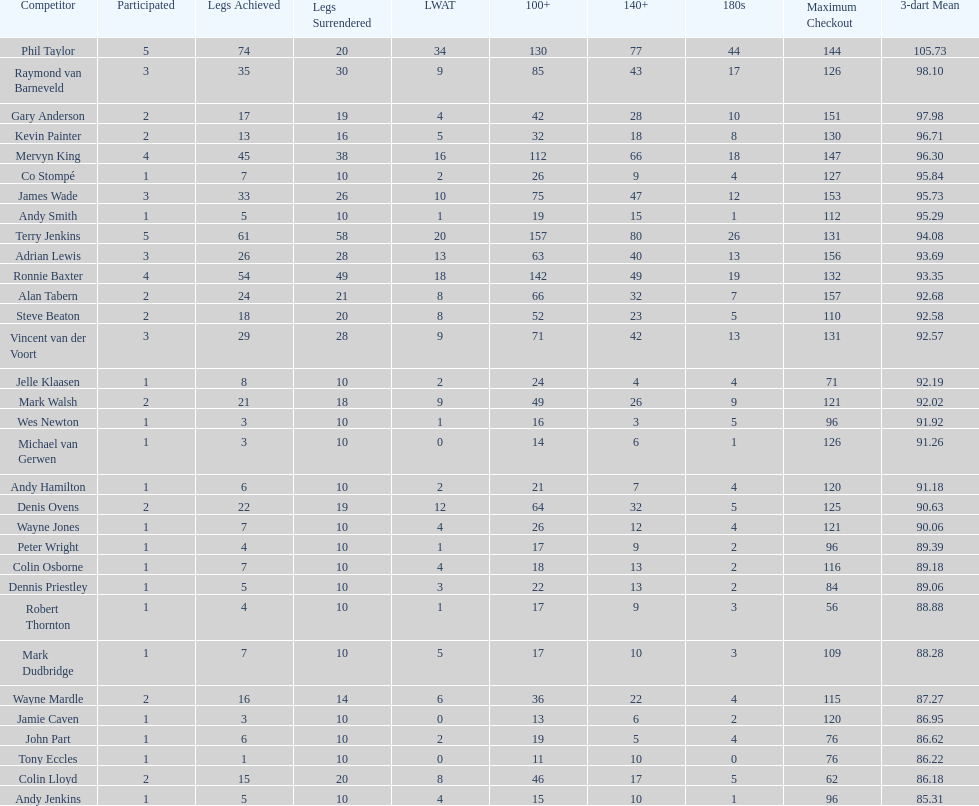Could you parse the entire table as a dict? {'header': ['Competitor', 'Participated', 'Legs Achieved', 'Legs Surrendered', 'LWAT', '100+', '140+', '180s', 'Maximum Checkout', '3-dart Mean'], 'rows': [['Phil Taylor', '5', '74', '20', '34', '130', '77', '44', '144', '105.73'], ['Raymond van Barneveld', '3', '35', '30', '9', '85', '43', '17', '126', '98.10'], ['Gary Anderson', '2', '17', '19', '4', '42', '28', '10', '151', '97.98'], ['Kevin Painter', '2', '13', '16', '5', '32', '18', '8', '130', '96.71'], ['Mervyn King', '4', '45', '38', '16', '112', '66', '18', '147', '96.30'], ['Co Stompé', '1', '7', '10', '2', '26', '9', '4', '127', '95.84'], ['James Wade', '3', '33', '26', '10', '75', '47', '12', '153', '95.73'], ['Andy Smith', '1', '5', '10', '1', '19', '15', '1', '112', '95.29'], ['Terry Jenkins', '5', '61', '58', '20', '157', '80', '26', '131', '94.08'], ['Adrian Lewis', '3', '26', '28', '13', '63', '40', '13', '156', '93.69'], ['Ronnie Baxter', '4', '54', '49', '18', '142', '49', '19', '132', '93.35'], ['Alan Tabern', '2', '24', '21', '8', '66', '32', '7', '157', '92.68'], ['Steve Beaton', '2', '18', '20', '8', '52', '23', '5', '110', '92.58'], ['Vincent van der Voort', '3', '29', '28', '9', '71', '42', '13', '131', '92.57'], ['Jelle Klaasen', '1', '8', '10', '2', '24', '4', '4', '71', '92.19'], ['Mark Walsh', '2', '21', '18', '9', '49', '26', '9', '121', '92.02'], ['Wes Newton', '1', '3', '10', '1', '16', '3', '5', '96', '91.92'], ['Michael van Gerwen', '1', '3', '10', '0', '14', '6', '1', '126', '91.26'], ['Andy Hamilton', '1', '6', '10', '2', '21', '7', '4', '120', '91.18'], ['Denis Ovens', '2', '22', '19', '12', '64', '32', '5', '125', '90.63'], ['Wayne Jones', '1', '7', '10', '4', '26', '12', '4', '121', '90.06'], ['Peter Wright', '1', '4', '10', '1', '17', '9', '2', '96', '89.39'], ['Colin Osborne', '1', '7', '10', '4', '18', '13', '2', '116', '89.18'], ['Dennis Priestley', '1', '5', '10', '3', '22', '13', '2', '84', '89.06'], ['Robert Thornton', '1', '4', '10', '1', '17', '9', '3', '56', '88.88'], ['Mark Dudbridge', '1', '7', '10', '5', '17', '10', '3', '109', '88.28'], ['Wayne Mardle', '2', '16', '14', '6', '36', '22', '4', '115', '87.27'], ['Jamie Caven', '1', '3', '10', '0', '13', '6', '2', '120', '86.95'], ['John Part', '1', '6', '10', '2', '19', '5', '4', '76', '86.62'], ['Tony Eccles', '1', '1', '10', '0', '11', '10', '0', '76', '86.22'], ['Colin Lloyd', '2', '15', '20', '8', '46', '17', '5', '62', '86.18'], ['Andy Jenkins', '1', '5', '10', '4', '15', '10', '1', '96', '85.31']]} What is the name of the next player after mark walsh? Wes Newton. 